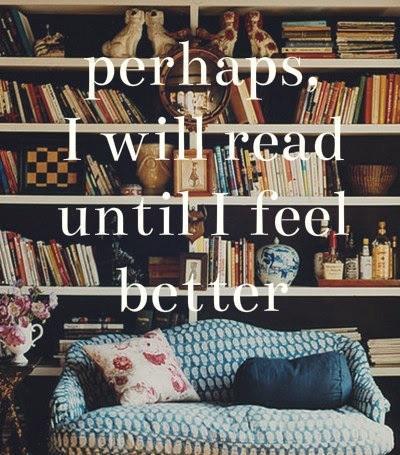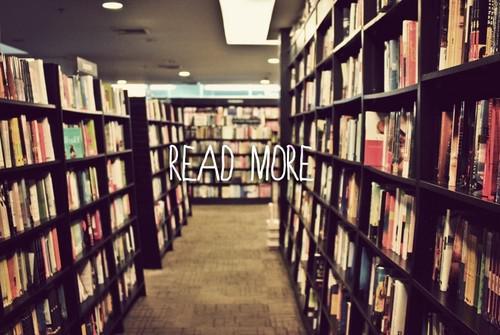The first image is the image on the left, the second image is the image on the right. Evaluate the accuracy of this statement regarding the images: "There is a person looking at a book.". Is it true? Answer yes or no. No. The first image is the image on the left, the second image is the image on the right. Evaluate the accuracy of this statement regarding the images: "Both images show large collections of books and no people can be seen in either.". Is it true? Answer yes or no. Yes. 